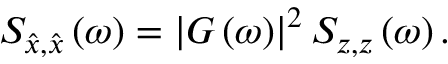Convert formula to latex. <formula><loc_0><loc_0><loc_500><loc_500>S _ { \hat { x } , \hat { x } } \left ( \omega \right ) = \left | G \left ( \omega \right ) \right | ^ { 2 } S _ { z , z } \left ( \omega \right ) .</formula> 